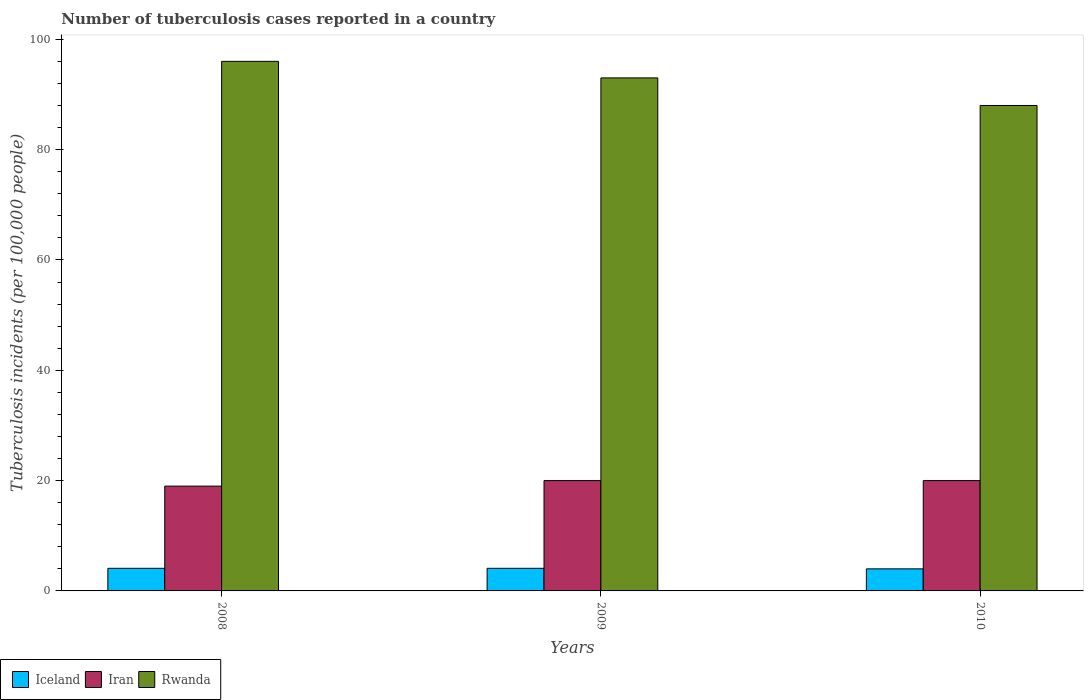Are the number of bars per tick equal to the number of legend labels?
Your answer should be very brief. Yes. Are the number of bars on each tick of the X-axis equal?
Make the answer very short. Yes. How many bars are there on the 2nd tick from the left?
Provide a succinct answer. 3. What is the label of the 2nd group of bars from the left?
Provide a short and direct response. 2009. In how many cases, is the number of bars for a given year not equal to the number of legend labels?
Ensure brevity in your answer.  0. What is the number of tuberculosis cases reported in in Iceland in 2009?
Your answer should be very brief. 4.1. Across all years, what is the maximum number of tuberculosis cases reported in in Iran?
Ensure brevity in your answer.  20. In which year was the number of tuberculosis cases reported in in Iran minimum?
Keep it short and to the point. 2008. What is the total number of tuberculosis cases reported in in Iran in the graph?
Ensure brevity in your answer.  59. What is the difference between the number of tuberculosis cases reported in in Iran in 2008 and that in 2010?
Your response must be concise. -1. What is the difference between the number of tuberculosis cases reported in in Iran in 2008 and the number of tuberculosis cases reported in in Rwanda in 2009?
Provide a succinct answer. -74. What is the average number of tuberculosis cases reported in in Iran per year?
Make the answer very short. 19.67. In the year 2009, what is the difference between the number of tuberculosis cases reported in in Iran and number of tuberculosis cases reported in in Iceland?
Provide a succinct answer. 15.9. In how many years, is the number of tuberculosis cases reported in in Rwanda greater than 12?
Your response must be concise. 3. What is the ratio of the number of tuberculosis cases reported in in Iceland in 2008 to that in 2010?
Keep it short and to the point. 1.02. Is the number of tuberculosis cases reported in in Iceland in 2009 less than that in 2010?
Provide a short and direct response. No. What is the difference between the highest and the lowest number of tuberculosis cases reported in in Iran?
Offer a terse response. 1. In how many years, is the number of tuberculosis cases reported in in Rwanda greater than the average number of tuberculosis cases reported in in Rwanda taken over all years?
Offer a terse response. 2. What does the 3rd bar from the left in 2009 represents?
Make the answer very short. Rwanda. What does the 1st bar from the right in 2009 represents?
Keep it short and to the point. Rwanda. Is it the case that in every year, the sum of the number of tuberculosis cases reported in in Iran and number of tuberculosis cases reported in in Iceland is greater than the number of tuberculosis cases reported in in Rwanda?
Give a very brief answer. No. Are the values on the major ticks of Y-axis written in scientific E-notation?
Provide a succinct answer. No. Does the graph contain any zero values?
Your answer should be very brief. No. Does the graph contain grids?
Make the answer very short. No. What is the title of the graph?
Your response must be concise. Number of tuberculosis cases reported in a country. What is the label or title of the Y-axis?
Offer a terse response. Tuberculosis incidents (per 100,0 people). What is the Tuberculosis incidents (per 100,000 people) in Iceland in 2008?
Keep it short and to the point. 4.1. What is the Tuberculosis incidents (per 100,000 people) in Rwanda in 2008?
Offer a terse response. 96. What is the Tuberculosis incidents (per 100,000 people) in Iran in 2009?
Your answer should be very brief. 20. What is the Tuberculosis incidents (per 100,000 people) in Rwanda in 2009?
Your response must be concise. 93. What is the Tuberculosis incidents (per 100,000 people) of Iran in 2010?
Provide a short and direct response. 20. What is the Tuberculosis incidents (per 100,000 people) of Rwanda in 2010?
Give a very brief answer. 88. Across all years, what is the maximum Tuberculosis incidents (per 100,000 people) in Iceland?
Your answer should be very brief. 4.1. Across all years, what is the maximum Tuberculosis incidents (per 100,000 people) in Iran?
Your response must be concise. 20. Across all years, what is the maximum Tuberculosis incidents (per 100,000 people) of Rwanda?
Your answer should be very brief. 96. Across all years, what is the minimum Tuberculosis incidents (per 100,000 people) of Iceland?
Offer a very short reply. 4. Across all years, what is the minimum Tuberculosis incidents (per 100,000 people) in Rwanda?
Provide a short and direct response. 88. What is the total Tuberculosis incidents (per 100,000 people) of Iran in the graph?
Your answer should be compact. 59. What is the total Tuberculosis incidents (per 100,000 people) of Rwanda in the graph?
Offer a terse response. 277. What is the difference between the Tuberculosis incidents (per 100,000 people) in Iceland in 2008 and that in 2009?
Make the answer very short. 0. What is the difference between the Tuberculosis incidents (per 100,000 people) of Iran in 2008 and that in 2009?
Your response must be concise. -1. What is the difference between the Tuberculosis incidents (per 100,000 people) in Rwanda in 2008 and that in 2009?
Ensure brevity in your answer.  3. What is the difference between the Tuberculosis incidents (per 100,000 people) of Iran in 2008 and that in 2010?
Your answer should be compact. -1. What is the difference between the Tuberculosis incidents (per 100,000 people) in Rwanda in 2008 and that in 2010?
Offer a very short reply. 8. What is the difference between the Tuberculosis incidents (per 100,000 people) in Iceland in 2009 and that in 2010?
Ensure brevity in your answer.  0.1. What is the difference between the Tuberculosis incidents (per 100,000 people) in Rwanda in 2009 and that in 2010?
Provide a short and direct response. 5. What is the difference between the Tuberculosis incidents (per 100,000 people) in Iceland in 2008 and the Tuberculosis incidents (per 100,000 people) in Iran in 2009?
Offer a very short reply. -15.9. What is the difference between the Tuberculosis incidents (per 100,000 people) in Iceland in 2008 and the Tuberculosis incidents (per 100,000 people) in Rwanda in 2009?
Your response must be concise. -88.9. What is the difference between the Tuberculosis incidents (per 100,000 people) in Iran in 2008 and the Tuberculosis incidents (per 100,000 people) in Rwanda in 2009?
Offer a very short reply. -74. What is the difference between the Tuberculosis incidents (per 100,000 people) in Iceland in 2008 and the Tuberculosis incidents (per 100,000 people) in Iran in 2010?
Ensure brevity in your answer.  -15.9. What is the difference between the Tuberculosis incidents (per 100,000 people) in Iceland in 2008 and the Tuberculosis incidents (per 100,000 people) in Rwanda in 2010?
Offer a very short reply. -83.9. What is the difference between the Tuberculosis incidents (per 100,000 people) of Iran in 2008 and the Tuberculosis incidents (per 100,000 people) of Rwanda in 2010?
Offer a terse response. -69. What is the difference between the Tuberculosis incidents (per 100,000 people) in Iceland in 2009 and the Tuberculosis incidents (per 100,000 people) in Iran in 2010?
Your answer should be very brief. -15.9. What is the difference between the Tuberculosis incidents (per 100,000 people) in Iceland in 2009 and the Tuberculosis incidents (per 100,000 people) in Rwanda in 2010?
Give a very brief answer. -83.9. What is the difference between the Tuberculosis incidents (per 100,000 people) of Iran in 2009 and the Tuberculosis incidents (per 100,000 people) of Rwanda in 2010?
Provide a succinct answer. -68. What is the average Tuberculosis incidents (per 100,000 people) of Iceland per year?
Offer a terse response. 4.07. What is the average Tuberculosis incidents (per 100,000 people) in Iran per year?
Keep it short and to the point. 19.67. What is the average Tuberculosis incidents (per 100,000 people) in Rwanda per year?
Give a very brief answer. 92.33. In the year 2008, what is the difference between the Tuberculosis incidents (per 100,000 people) of Iceland and Tuberculosis incidents (per 100,000 people) of Iran?
Your answer should be very brief. -14.9. In the year 2008, what is the difference between the Tuberculosis incidents (per 100,000 people) of Iceland and Tuberculosis incidents (per 100,000 people) of Rwanda?
Make the answer very short. -91.9. In the year 2008, what is the difference between the Tuberculosis incidents (per 100,000 people) in Iran and Tuberculosis incidents (per 100,000 people) in Rwanda?
Offer a very short reply. -77. In the year 2009, what is the difference between the Tuberculosis incidents (per 100,000 people) of Iceland and Tuberculosis incidents (per 100,000 people) of Iran?
Your response must be concise. -15.9. In the year 2009, what is the difference between the Tuberculosis incidents (per 100,000 people) in Iceland and Tuberculosis incidents (per 100,000 people) in Rwanda?
Provide a succinct answer. -88.9. In the year 2009, what is the difference between the Tuberculosis incidents (per 100,000 people) of Iran and Tuberculosis incidents (per 100,000 people) of Rwanda?
Provide a short and direct response. -73. In the year 2010, what is the difference between the Tuberculosis incidents (per 100,000 people) in Iceland and Tuberculosis incidents (per 100,000 people) in Iran?
Offer a terse response. -16. In the year 2010, what is the difference between the Tuberculosis incidents (per 100,000 people) in Iceland and Tuberculosis incidents (per 100,000 people) in Rwanda?
Keep it short and to the point. -84. In the year 2010, what is the difference between the Tuberculosis incidents (per 100,000 people) of Iran and Tuberculosis incidents (per 100,000 people) of Rwanda?
Give a very brief answer. -68. What is the ratio of the Tuberculosis incidents (per 100,000 people) of Iceland in 2008 to that in 2009?
Make the answer very short. 1. What is the ratio of the Tuberculosis incidents (per 100,000 people) in Iran in 2008 to that in 2009?
Keep it short and to the point. 0.95. What is the ratio of the Tuberculosis incidents (per 100,000 people) in Rwanda in 2008 to that in 2009?
Your response must be concise. 1.03. What is the ratio of the Tuberculosis incidents (per 100,000 people) in Rwanda in 2008 to that in 2010?
Give a very brief answer. 1.09. What is the ratio of the Tuberculosis incidents (per 100,000 people) in Iceland in 2009 to that in 2010?
Give a very brief answer. 1.02. What is the ratio of the Tuberculosis incidents (per 100,000 people) in Iran in 2009 to that in 2010?
Give a very brief answer. 1. What is the ratio of the Tuberculosis incidents (per 100,000 people) in Rwanda in 2009 to that in 2010?
Your response must be concise. 1.06. What is the difference between the highest and the second highest Tuberculosis incidents (per 100,000 people) of Iran?
Provide a succinct answer. 0. 